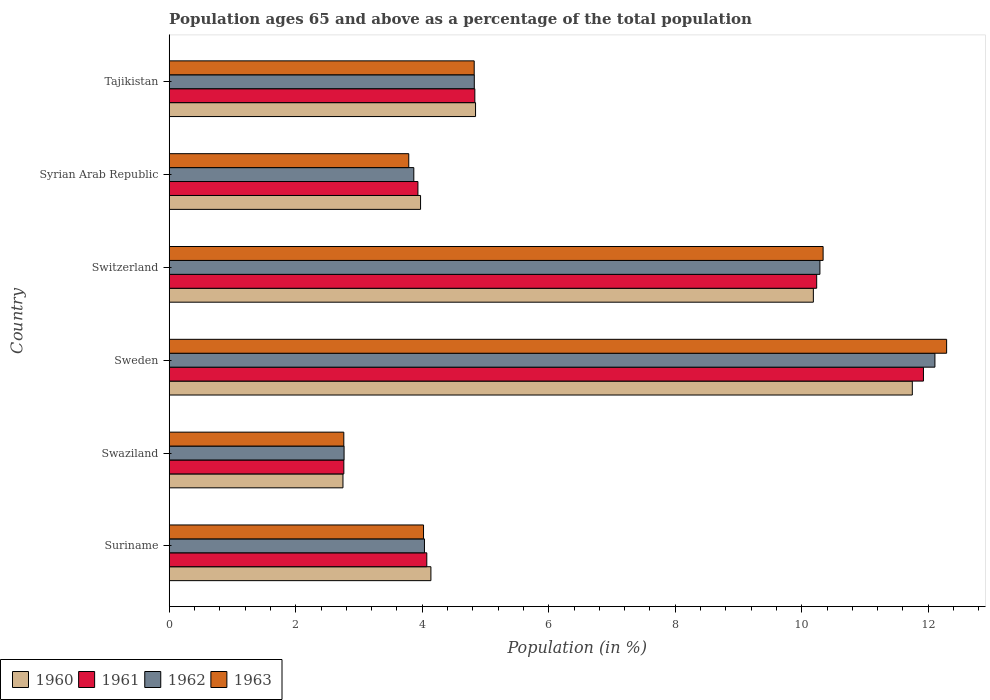How many different coloured bars are there?
Give a very brief answer. 4. Are the number of bars on each tick of the Y-axis equal?
Offer a terse response. Yes. What is the label of the 3rd group of bars from the top?
Provide a succinct answer. Switzerland. What is the percentage of the population ages 65 and above in 1963 in Sweden?
Give a very brief answer. 12.29. Across all countries, what is the maximum percentage of the population ages 65 and above in 1962?
Provide a short and direct response. 12.11. Across all countries, what is the minimum percentage of the population ages 65 and above in 1961?
Your answer should be very brief. 2.76. In which country was the percentage of the population ages 65 and above in 1963 maximum?
Your response must be concise. Sweden. In which country was the percentage of the population ages 65 and above in 1962 minimum?
Make the answer very short. Swaziland. What is the total percentage of the population ages 65 and above in 1960 in the graph?
Offer a very short reply. 37.63. What is the difference between the percentage of the population ages 65 and above in 1961 in Suriname and that in Syrian Arab Republic?
Your answer should be compact. 0.14. What is the difference between the percentage of the population ages 65 and above in 1960 in Switzerland and the percentage of the population ages 65 and above in 1962 in Sweden?
Your answer should be very brief. -1.92. What is the average percentage of the population ages 65 and above in 1961 per country?
Offer a very short reply. 6.29. What is the difference between the percentage of the population ages 65 and above in 1960 and percentage of the population ages 65 and above in 1963 in Swaziland?
Provide a short and direct response. -0.01. In how many countries, is the percentage of the population ages 65 and above in 1962 greater than 4 ?
Your answer should be compact. 4. What is the ratio of the percentage of the population ages 65 and above in 1961 in Swaziland to that in Switzerland?
Keep it short and to the point. 0.27. What is the difference between the highest and the second highest percentage of the population ages 65 and above in 1963?
Provide a succinct answer. 1.95. What is the difference between the highest and the lowest percentage of the population ages 65 and above in 1961?
Your answer should be very brief. 9.16. What does the 1st bar from the top in Sweden represents?
Your answer should be compact. 1963. Are all the bars in the graph horizontal?
Make the answer very short. Yes. Are the values on the major ticks of X-axis written in scientific E-notation?
Your response must be concise. No. Does the graph contain any zero values?
Make the answer very short. No. Where does the legend appear in the graph?
Offer a very short reply. Bottom left. How many legend labels are there?
Your answer should be compact. 4. How are the legend labels stacked?
Provide a succinct answer. Horizontal. What is the title of the graph?
Provide a short and direct response. Population ages 65 and above as a percentage of the total population. Does "2014" appear as one of the legend labels in the graph?
Offer a terse response. No. What is the label or title of the Y-axis?
Your answer should be compact. Country. What is the Population (in %) in 1960 in Suriname?
Provide a succinct answer. 4.14. What is the Population (in %) in 1961 in Suriname?
Make the answer very short. 4.07. What is the Population (in %) of 1962 in Suriname?
Ensure brevity in your answer.  4.04. What is the Population (in %) of 1963 in Suriname?
Your answer should be compact. 4.02. What is the Population (in %) of 1960 in Swaziland?
Provide a short and direct response. 2.75. What is the Population (in %) of 1961 in Swaziland?
Provide a succinct answer. 2.76. What is the Population (in %) in 1962 in Swaziland?
Provide a succinct answer. 2.76. What is the Population (in %) in 1963 in Swaziland?
Your response must be concise. 2.76. What is the Population (in %) in 1960 in Sweden?
Provide a succinct answer. 11.75. What is the Population (in %) in 1961 in Sweden?
Your response must be concise. 11.92. What is the Population (in %) of 1962 in Sweden?
Your response must be concise. 12.11. What is the Population (in %) in 1963 in Sweden?
Ensure brevity in your answer.  12.29. What is the Population (in %) in 1960 in Switzerland?
Ensure brevity in your answer.  10.18. What is the Population (in %) in 1961 in Switzerland?
Provide a short and direct response. 10.24. What is the Population (in %) in 1962 in Switzerland?
Give a very brief answer. 10.29. What is the Population (in %) in 1963 in Switzerland?
Your response must be concise. 10.34. What is the Population (in %) in 1960 in Syrian Arab Republic?
Make the answer very short. 3.97. What is the Population (in %) in 1961 in Syrian Arab Republic?
Make the answer very short. 3.93. What is the Population (in %) of 1962 in Syrian Arab Republic?
Offer a terse response. 3.87. What is the Population (in %) of 1963 in Syrian Arab Republic?
Make the answer very short. 3.79. What is the Population (in %) of 1960 in Tajikistan?
Offer a very short reply. 4.84. What is the Population (in %) of 1961 in Tajikistan?
Keep it short and to the point. 4.83. What is the Population (in %) of 1962 in Tajikistan?
Ensure brevity in your answer.  4.82. What is the Population (in %) in 1963 in Tajikistan?
Your answer should be compact. 4.82. Across all countries, what is the maximum Population (in %) in 1960?
Make the answer very short. 11.75. Across all countries, what is the maximum Population (in %) of 1961?
Provide a short and direct response. 11.92. Across all countries, what is the maximum Population (in %) of 1962?
Give a very brief answer. 12.11. Across all countries, what is the maximum Population (in %) in 1963?
Offer a terse response. 12.29. Across all countries, what is the minimum Population (in %) of 1960?
Your answer should be very brief. 2.75. Across all countries, what is the minimum Population (in %) in 1961?
Offer a terse response. 2.76. Across all countries, what is the minimum Population (in %) of 1962?
Provide a succinct answer. 2.76. Across all countries, what is the minimum Population (in %) of 1963?
Your response must be concise. 2.76. What is the total Population (in %) of 1960 in the graph?
Ensure brevity in your answer.  37.63. What is the total Population (in %) of 1961 in the graph?
Offer a very short reply. 37.76. What is the total Population (in %) in 1962 in the graph?
Your answer should be very brief. 37.88. What is the total Population (in %) of 1963 in the graph?
Provide a succinct answer. 38.02. What is the difference between the Population (in %) of 1960 in Suriname and that in Swaziland?
Give a very brief answer. 1.39. What is the difference between the Population (in %) in 1961 in Suriname and that in Swaziland?
Provide a short and direct response. 1.31. What is the difference between the Population (in %) in 1962 in Suriname and that in Swaziland?
Offer a very short reply. 1.27. What is the difference between the Population (in %) in 1963 in Suriname and that in Swaziland?
Ensure brevity in your answer.  1.26. What is the difference between the Population (in %) of 1960 in Suriname and that in Sweden?
Offer a terse response. -7.61. What is the difference between the Population (in %) in 1961 in Suriname and that in Sweden?
Provide a short and direct response. -7.85. What is the difference between the Population (in %) of 1962 in Suriname and that in Sweden?
Provide a succinct answer. -8.07. What is the difference between the Population (in %) in 1963 in Suriname and that in Sweden?
Keep it short and to the point. -8.27. What is the difference between the Population (in %) of 1960 in Suriname and that in Switzerland?
Provide a short and direct response. -6.05. What is the difference between the Population (in %) in 1961 in Suriname and that in Switzerland?
Your answer should be compact. -6.16. What is the difference between the Population (in %) of 1962 in Suriname and that in Switzerland?
Your answer should be compact. -6.25. What is the difference between the Population (in %) of 1963 in Suriname and that in Switzerland?
Provide a succinct answer. -6.32. What is the difference between the Population (in %) in 1960 in Suriname and that in Syrian Arab Republic?
Offer a very short reply. 0.16. What is the difference between the Population (in %) of 1961 in Suriname and that in Syrian Arab Republic?
Ensure brevity in your answer.  0.14. What is the difference between the Population (in %) of 1962 in Suriname and that in Syrian Arab Republic?
Your answer should be compact. 0.17. What is the difference between the Population (in %) in 1963 in Suriname and that in Syrian Arab Republic?
Your answer should be compact. 0.23. What is the difference between the Population (in %) of 1960 in Suriname and that in Tajikistan?
Offer a very short reply. -0.71. What is the difference between the Population (in %) of 1961 in Suriname and that in Tajikistan?
Provide a short and direct response. -0.76. What is the difference between the Population (in %) in 1962 in Suriname and that in Tajikistan?
Give a very brief answer. -0.79. What is the difference between the Population (in %) of 1963 in Suriname and that in Tajikistan?
Provide a short and direct response. -0.8. What is the difference between the Population (in %) of 1960 in Swaziland and that in Sweden?
Provide a short and direct response. -9. What is the difference between the Population (in %) of 1961 in Swaziland and that in Sweden?
Provide a short and direct response. -9.16. What is the difference between the Population (in %) of 1962 in Swaziland and that in Sweden?
Offer a very short reply. -9.34. What is the difference between the Population (in %) of 1963 in Swaziland and that in Sweden?
Provide a succinct answer. -9.53. What is the difference between the Population (in %) in 1960 in Swaziland and that in Switzerland?
Offer a terse response. -7.44. What is the difference between the Population (in %) in 1961 in Swaziland and that in Switzerland?
Your response must be concise. -7.48. What is the difference between the Population (in %) in 1962 in Swaziland and that in Switzerland?
Offer a very short reply. -7.52. What is the difference between the Population (in %) in 1963 in Swaziland and that in Switzerland?
Provide a short and direct response. -7.58. What is the difference between the Population (in %) in 1960 in Swaziland and that in Syrian Arab Republic?
Your answer should be very brief. -1.23. What is the difference between the Population (in %) in 1961 in Swaziland and that in Syrian Arab Republic?
Keep it short and to the point. -1.17. What is the difference between the Population (in %) in 1962 in Swaziland and that in Syrian Arab Republic?
Your response must be concise. -1.1. What is the difference between the Population (in %) of 1963 in Swaziland and that in Syrian Arab Republic?
Provide a short and direct response. -1.03. What is the difference between the Population (in %) in 1960 in Swaziland and that in Tajikistan?
Offer a terse response. -2.1. What is the difference between the Population (in %) of 1961 in Swaziland and that in Tajikistan?
Ensure brevity in your answer.  -2.07. What is the difference between the Population (in %) in 1962 in Swaziland and that in Tajikistan?
Offer a terse response. -2.06. What is the difference between the Population (in %) of 1963 in Swaziland and that in Tajikistan?
Ensure brevity in your answer.  -2.06. What is the difference between the Population (in %) of 1960 in Sweden and that in Switzerland?
Provide a succinct answer. 1.56. What is the difference between the Population (in %) in 1961 in Sweden and that in Switzerland?
Make the answer very short. 1.69. What is the difference between the Population (in %) in 1962 in Sweden and that in Switzerland?
Provide a succinct answer. 1.82. What is the difference between the Population (in %) of 1963 in Sweden and that in Switzerland?
Give a very brief answer. 1.95. What is the difference between the Population (in %) of 1960 in Sweden and that in Syrian Arab Republic?
Give a very brief answer. 7.77. What is the difference between the Population (in %) in 1961 in Sweden and that in Syrian Arab Republic?
Ensure brevity in your answer.  7.99. What is the difference between the Population (in %) of 1962 in Sweden and that in Syrian Arab Republic?
Make the answer very short. 8.24. What is the difference between the Population (in %) in 1963 in Sweden and that in Syrian Arab Republic?
Give a very brief answer. 8.5. What is the difference between the Population (in %) in 1960 in Sweden and that in Tajikistan?
Ensure brevity in your answer.  6.91. What is the difference between the Population (in %) in 1961 in Sweden and that in Tajikistan?
Ensure brevity in your answer.  7.09. What is the difference between the Population (in %) of 1962 in Sweden and that in Tajikistan?
Your answer should be compact. 7.28. What is the difference between the Population (in %) in 1963 in Sweden and that in Tajikistan?
Offer a terse response. 7.47. What is the difference between the Population (in %) of 1960 in Switzerland and that in Syrian Arab Republic?
Make the answer very short. 6.21. What is the difference between the Population (in %) of 1961 in Switzerland and that in Syrian Arab Republic?
Offer a terse response. 6.3. What is the difference between the Population (in %) in 1962 in Switzerland and that in Syrian Arab Republic?
Keep it short and to the point. 6.42. What is the difference between the Population (in %) in 1963 in Switzerland and that in Syrian Arab Republic?
Provide a succinct answer. 6.55. What is the difference between the Population (in %) of 1960 in Switzerland and that in Tajikistan?
Make the answer very short. 5.34. What is the difference between the Population (in %) in 1961 in Switzerland and that in Tajikistan?
Your response must be concise. 5.4. What is the difference between the Population (in %) in 1962 in Switzerland and that in Tajikistan?
Your response must be concise. 5.46. What is the difference between the Population (in %) of 1963 in Switzerland and that in Tajikistan?
Keep it short and to the point. 5.52. What is the difference between the Population (in %) in 1960 in Syrian Arab Republic and that in Tajikistan?
Keep it short and to the point. -0.87. What is the difference between the Population (in %) of 1961 in Syrian Arab Republic and that in Tajikistan?
Keep it short and to the point. -0.9. What is the difference between the Population (in %) of 1962 in Syrian Arab Republic and that in Tajikistan?
Your response must be concise. -0.96. What is the difference between the Population (in %) of 1963 in Syrian Arab Republic and that in Tajikistan?
Make the answer very short. -1.03. What is the difference between the Population (in %) in 1960 in Suriname and the Population (in %) in 1961 in Swaziland?
Offer a terse response. 1.38. What is the difference between the Population (in %) of 1960 in Suriname and the Population (in %) of 1962 in Swaziland?
Offer a terse response. 1.37. What is the difference between the Population (in %) of 1960 in Suriname and the Population (in %) of 1963 in Swaziland?
Offer a very short reply. 1.38. What is the difference between the Population (in %) of 1961 in Suriname and the Population (in %) of 1962 in Swaziland?
Offer a very short reply. 1.31. What is the difference between the Population (in %) in 1961 in Suriname and the Population (in %) in 1963 in Swaziland?
Offer a terse response. 1.31. What is the difference between the Population (in %) of 1962 in Suriname and the Population (in %) of 1963 in Swaziland?
Your response must be concise. 1.27. What is the difference between the Population (in %) in 1960 in Suriname and the Population (in %) in 1961 in Sweden?
Keep it short and to the point. -7.79. What is the difference between the Population (in %) of 1960 in Suriname and the Population (in %) of 1962 in Sweden?
Your answer should be very brief. -7.97. What is the difference between the Population (in %) in 1960 in Suriname and the Population (in %) in 1963 in Sweden?
Make the answer very short. -8.15. What is the difference between the Population (in %) of 1961 in Suriname and the Population (in %) of 1962 in Sweden?
Provide a short and direct response. -8.03. What is the difference between the Population (in %) in 1961 in Suriname and the Population (in %) in 1963 in Sweden?
Your answer should be very brief. -8.22. What is the difference between the Population (in %) of 1962 in Suriname and the Population (in %) of 1963 in Sweden?
Offer a very short reply. -8.26. What is the difference between the Population (in %) in 1960 in Suriname and the Population (in %) in 1961 in Switzerland?
Your answer should be compact. -6.1. What is the difference between the Population (in %) in 1960 in Suriname and the Population (in %) in 1962 in Switzerland?
Offer a very short reply. -6.15. What is the difference between the Population (in %) of 1960 in Suriname and the Population (in %) of 1963 in Switzerland?
Provide a short and direct response. -6.2. What is the difference between the Population (in %) of 1961 in Suriname and the Population (in %) of 1962 in Switzerland?
Keep it short and to the point. -6.22. What is the difference between the Population (in %) of 1961 in Suriname and the Population (in %) of 1963 in Switzerland?
Your response must be concise. -6.27. What is the difference between the Population (in %) in 1962 in Suriname and the Population (in %) in 1963 in Switzerland?
Keep it short and to the point. -6.3. What is the difference between the Population (in %) in 1960 in Suriname and the Population (in %) in 1961 in Syrian Arab Republic?
Provide a short and direct response. 0.21. What is the difference between the Population (in %) of 1960 in Suriname and the Population (in %) of 1962 in Syrian Arab Republic?
Your response must be concise. 0.27. What is the difference between the Population (in %) of 1960 in Suriname and the Population (in %) of 1963 in Syrian Arab Republic?
Provide a succinct answer. 0.35. What is the difference between the Population (in %) of 1961 in Suriname and the Population (in %) of 1962 in Syrian Arab Republic?
Your response must be concise. 0.21. What is the difference between the Population (in %) in 1961 in Suriname and the Population (in %) in 1963 in Syrian Arab Republic?
Provide a short and direct response. 0.29. What is the difference between the Population (in %) in 1962 in Suriname and the Population (in %) in 1963 in Syrian Arab Republic?
Your answer should be very brief. 0.25. What is the difference between the Population (in %) in 1960 in Suriname and the Population (in %) in 1961 in Tajikistan?
Make the answer very short. -0.69. What is the difference between the Population (in %) of 1960 in Suriname and the Population (in %) of 1962 in Tajikistan?
Your response must be concise. -0.69. What is the difference between the Population (in %) in 1960 in Suriname and the Population (in %) in 1963 in Tajikistan?
Provide a succinct answer. -0.68. What is the difference between the Population (in %) in 1961 in Suriname and the Population (in %) in 1962 in Tajikistan?
Offer a terse response. -0.75. What is the difference between the Population (in %) of 1961 in Suriname and the Population (in %) of 1963 in Tajikistan?
Offer a terse response. -0.75. What is the difference between the Population (in %) of 1962 in Suriname and the Population (in %) of 1963 in Tajikistan?
Your response must be concise. -0.79. What is the difference between the Population (in %) in 1960 in Swaziland and the Population (in %) in 1961 in Sweden?
Offer a very short reply. -9.18. What is the difference between the Population (in %) in 1960 in Swaziland and the Population (in %) in 1962 in Sweden?
Offer a terse response. -9.36. What is the difference between the Population (in %) in 1960 in Swaziland and the Population (in %) in 1963 in Sweden?
Make the answer very short. -9.54. What is the difference between the Population (in %) in 1961 in Swaziland and the Population (in %) in 1962 in Sweden?
Your answer should be very brief. -9.35. What is the difference between the Population (in %) of 1961 in Swaziland and the Population (in %) of 1963 in Sweden?
Give a very brief answer. -9.53. What is the difference between the Population (in %) of 1962 in Swaziland and the Population (in %) of 1963 in Sweden?
Make the answer very short. -9.53. What is the difference between the Population (in %) of 1960 in Swaziland and the Population (in %) of 1961 in Switzerland?
Make the answer very short. -7.49. What is the difference between the Population (in %) of 1960 in Swaziland and the Population (in %) of 1962 in Switzerland?
Provide a short and direct response. -7.54. What is the difference between the Population (in %) of 1960 in Swaziland and the Population (in %) of 1963 in Switzerland?
Ensure brevity in your answer.  -7.59. What is the difference between the Population (in %) in 1961 in Swaziland and the Population (in %) in 1962 in Switzerland?
Provide a succinct answer. -7.53. What is the difference between the Population (in %) in 1961 in Swaziland and the Population (in %) in 1963 in Switzerland?
Give a very brief answer. -7.58. What is the difference between the Population (in %) of 1962 in Swaziland and the Population (in %) of 1963 in Switzerland?
Make the answer very short. -7.57. What is the difference between the Population (in %) in 1960 in Swaziland and the Population (in %) in 1961 in Syrian Arab Republic?
Provide a succinct answer. -1.19. What is the difference between the Population (in %) in 1960 in Swaziland and the Population (in %) in 1962 in Syrian Arab Republic?
Provide a succinct answer. -1.12. What is the difference between the Population (in %) in 1960 in Swaziland and the Population (in %) in 1963 in Syrian Arab Republic?
Ensure brevity in your answer.  -1.04. What is the difference between the Population (in %) in 1961 in Swaziland and the Population (in %) in 1962 in Syrian Arab Republic?
Keep it short and to the point. -1.11. What is the difference between the Population (in %) of 1961 in Swaziland and the Population (in %) of 1963 in Syrian Arab Republic?
Provide a succinct answer. -1.03. What is the difference between the Population (in %) in 1962 in Swaziland and the Population (in %) in 1963 in Syrian Arab Republic?
Your response must be concise. -1.02. What is the difference between the Population (in %) in 1960 in Swaziland and the Population (in %) in 1961 in Tajikistan?
Ensure brevity in your answer.  -2.09. What is the difference between the Population (in %) of 1960 in Swaziland and the Population (in %) of 1962 in Tajikistan?
Your answer should be very brief. -2.08. What is the difference between the Population (in %) of 1960 in Swaziland and the Population (in %) of 1963 in Tajikistan?
Provide a short and direct response. -2.07. What is the difference between the Population (in %) in 1961 in Swaziland and the Population (in %) in 1962 in Tajikistan?
Give a very brief answer. -2.06. What is the difference between the Population (in %) of 1961 in Swaziland and the Population (in %) of 1963 in Tajikistan?
Provide a short and direct response. -2.06. What is the difference between the Population (in %) in 1962 in Swaziland and the Population (in %) in 1963 in Tajikistan?
Provide a succinct answer. -2.06. What is the difference between the Population (in %) of 1960 in Sweden and the Population (in %) of 1961 in Switzerland?
Your response must be concise. 1.51. What is the difference between the Population (in %) of 1960 in Sweden and the Population (in %) of 1962 in Switzerland?
Offer a terse response. 1.46. What is the difference between the Population (in %) of 1960 in Sweden and the Population (in %) of 1963 in Switzerland?
Give a very brief answer. 1.41. What is the difference between the Population (in %) of 1961 in Sweden and the Population (in %) of 1962 in Switzerland?
Offer a very short reply. 1.64. What is the difference between the Population (in %) in 1961 in Sweden and the Population (in %) in 1963 in Switzerland?
Make the answer very short. 1.59. What is the difference between the Population (in %) of 1962 in Sweden and the Population (in %) of 1963 in Switzerland?
Provide a succinct answer. 1.77. What is the difference between the Population (in %) in 1960 in Sweden and the Population (in %) in 1961 in Syrian Arab Republic?
Offer a very short reply. 7.82. What is the difference between the Population (in %) of 1960 in Sweden and the Population (in %) of 1962 in Syrian Arab Republic?
Your answer should be compact. 7.88. What is the difference between the Population (in %) in 1960 in Sweden and the Population (in %) in 1963 in Syrian Arab Republic?
Ensure brevity in your answer.  7.96. What is the difference between the Population (in %) in 1961 in Sweden and the Population (in %) in 1962 in Syrian Arab Republic?
Ensure brevity in your answer.  8.06. What is the difference between the Population (in %) of 1961 in Sweden and the Population (in %) of 1963 in Syrian Arab Republic?
Your answer should be very brief. 8.14. What is the difference between the Population (in %) of 1962 in Sweden and the Population (in %) of 1963 in Syrian Arab Republic?
Your answer should be very brief. 8.32. What is the difference between the Population (in %) of 1960 in Sweden and the Population (in %) of 1961 in Tajikistan?
Your response must be concise. 6.92. What is the difference between the Population (in %) of 1960 in Sweden and the Population (in %) of 1962 in Tajikistan?
Your answer should be compact. 6.93. What is the difference between the Population (in %) of 1960 in Sweden and the Population (in %) of 1963 in Tajikistan?
Make the answer very short. 6.93. What is the difference between the Population (in %) of 1961 in Sweden and the Population (in %) of 1962 in Tajikistan?
Keep it short and to the point. 7.1. What is the difference between the Population (in %) in 1961 in Sweden and the Population (in %) in 1963 in Tajikistan?
Provide a short and direct response. 7.1. What is the difference between the Population (in %) in 1962 in Sweden and the Population (in %) in 1963 in Tajikistan?
Give a very brief answer. 7.28. What is the difference between the Population (in %) of 1960 in Switzerland and the Population (in %) of 1961 in Syrian Arab Republic?
Make the answer very short. 6.25. What is the difference between the Population (in %) of 1960 in Switzerland and the Population (in %) of 1962 in Syrian Arab Republic?
Provide a succinct answer. 6.32. What is the difference between the Population (in %) in 1960 in Switzerland and the Population (in %) in 1963 in Syrian Arab Republic?
Ensure brevity in your answer.  6.4. What is the difference between the Population (in %) in 1961 in Switzerland and the Population (in %) in 1962 in Syrian Arab Republic?
Your response must be concise. 6.37. What is the difference between the Population (in %) of 1961 in Switzerland and the Population (in %) of 1963 in Syrian Arab Republic?
Provide a succinct answer. 6.45. What is the difference between the Population (in %) of 1962 in Switzerland and the Population (in %) of 1963 in Syrian Arab Republic?
Ensure brevity in your answer.  6.5. What is the difference between the Population (in %) of 1960 in Switzerland and the Population (in %) of 1961 in Tajikistan?
Offer a very short reply. 5.35. What is the difference between the Population (in %) of 1960 in Switzerland and the Population (in %) of 1962 in Tajikistan?
Keep it short and to the point. 5.36. What is the difference between the Population (in %) of 1960 in Switzerland and the Population (in %) of 1963 in Tajikistan?
Offer a terse response. 5.36. What is the difference between the Population (in %) in 1961 in Switzerland and the Population (in %) in 1962 in Tajikistan?
Offer a terse response. 5.41. What is the difference between the Population (in %) in 1961 in Switzerland and the Population (in %) in 1963 in Tajikistan?
Offer a terse response. 5.41. What is the difference between the Population (in %) in 1962 in Switzerland and the Population (in %) in 1963 in Tajikistan?
Ensure brevity in your answer.  5.47. What is the difference between the Population (in %) of 1960 in Syrian Arab Republic and the Population (in %) of 1961 in Tajikistan?
Offer a terse response. -0.86. What is the difference between the Population (in %) of 1960 in Syrian Arab Republic and the Population (in %) of 1962 in Tajikistan?
Your response must be concise. -0.85. What is the difference between the Population (in %) in 1960 in Syrian Arab Republic and the Population (in %) in 1963 in Tajikistan?
Provide a short and direct response. -0.85. What is the difference between the Population (in %) in 1961 in Syrian Arab Republic and the Population (in %) in 1962 in Tajikistan?
Your response must be concise. -0.89. What is the difference between the Population (in %) in 1961 in Syrian Arab Republic and the Population (in %) in 1963 in Tajikistan?
Keep it short and to the point. -0.89. What is the difference between the Population (in %) in 1962 in Syrian Arab Republic and the Population (in %) in 1963 in Tajikistan?
Make the answer very short. -0.95. What is the average Population (in %) of 1960 per country?
Provide a succinct answer. 6.27. What is the average Population (in %) of 1961 per country?
Provide a short and direct response. 6.29. What is the average Population (in %) of 1962 per country?
Ensure brevity in your answer.  6.31. What is the average Population (in %) of 1963 per country?
Your response must be concise. 6.34. What is the difference between the Population (in %) of 1960 and Population (in %) of 1961 in Suriname?
Keep it short and to the point. 0.07. What is the difference between the Population (in %) of 1960 and Population (in %) of 1962 in Suriname?
Your answer should be compact. 0.1. What is the difference between the Population (in %) in 1960 and Population (in %) in 1963 in Suriname?
Offer a terse response. 0.12. What is the difference between the Population (in %) of 1961 and Population (in %) of 1962 in Suriname?
Provide a short and direct response. 0.04. What is the difference between the Population (in %) in 1961 and Population (in %) in 1963 in Suriname?
Offer a terse response. 0.05. What is the difference between the Population (in %) of 1962 and Population (in %) of 1963 in Suriname?
Offer a terse response. 0.01. What is the difference between the Population (in %) in 1960 and Population (in %) in 1961 in Swaziland?
Provide a succinct answer. -0.01. What is the difference between the Population (in %) of 1960 and Population (in %) of 1962 in Swaziland?
Provide a short and direct response. -0.02. What is the difference between the Population (in %) in 1960 and Population (in %) in 1963 in Swaziland?
Offer a very short reply. -0.01. What is the difference between the Population (in %) of 1961 and Population (in %) of 1962 in Swaziland?
Keep it short and to the point. -0. What is the difference between the Population (in %) of 1961 and Population (in %) of 1963 in Swaziland?
Offer a very short reply. 0. What is the difference between the Population (in %) in 1962 and Population (in %) in 1963 in Swaziland?
Keep it short and to the point. 0. What is the difference between the Population (in %) in 1960 and Population (in %) in 1961 in Sweden?
Keep it short and to the point. -0.18. What is the difference between the Population (in %) in 1960 and Population (in %) in 1962 in Sweden?
Provide a succinct answer. -0.36. What is the difference between the Population (in %) of 1960 and Population (in %) of 1963 in Sweden?
Your answer should be very brief. -0.54. What is the difference between the Population (in %) in 1961 and Population (in %) in 1962 in Sweden?
Make the answer very short. -0.18. What is the difference between the Population (in %) in 1961 and Population (in %) in 1963 in Sweden?
Keep it short and to the point. -0.37. What is the difference between the Population (in %) of 1962 and Population (in %) of 1963 in Sweden?
Offer a terse response. -0.18. What is the difference between the Population (in %) of 1960 and Population (in %) of 1961 in Switzerland?
Provide a short and direct response. -0.05. What is the difference between the Population (in %) of 1960 and Population (in %) of 1962 in Switzerland?
Your response must be concise. -0.1. What is the difference between the Population (in %) in 1960 and Population (in %) in 1963 in Switzerland?
Provide a short and direct response. -0.15. What is the difference between the Population (in %) of 1961 and Population (in %) of 1962 in Switzerland?
Your answer should be compact. -0.05. What is the difference between the Population (in %) of 1961 and Population (in %) of 1963 in Switzerland?
Your answer should be very brief. -0.1. What is the difference between the Population (in %) in 1962 and Population (in %) in 1963 in Switzerland?
Ensure brevity in your answer.  -0.05. What is the difference between the Population (in %) of 1960 and Population (in %) of 1961 in Syrian Arab Republic?
Keep it short and to the point. 0.04. What is the difference between the Population (in %) in 1960 and Population (in %) in 1962 in Syrian Arab Republic?
Provide a succinct answer. 0.11. What is the difference between the Population (in %) of 1960 and Population (in %) of 1963 in Syrian Arab Republic?
Offer a very short reply. 0.19. What is the difference between the Population (in %) of 1961 and Population (in %) of 1962 in Syrian Arab Republic?
Provide a succinct answer. 0.07. What is the difference between the Population (in %) of 1961 and Population (in %) of 1963 in Syrian Arab Republic?
Your answer should be very brief. 0.14. What is the difference between the Population (in %) of 1962 and Population (in %) of 1963 in Syrian Arab Republic?
Your answer should be compact. 0.08. What is the difference between the Population (in %) of 1960 and Population (in %) of 1961 in Tajikistan?
Ensure brevity in your answer.  0.01. What is the difference between the Population (in %) in 1960 and Population (in %) in 1962 in Tajikistan?
Make the answer very short. 0.02. What is the difference between the Population (in %) of 1960 and Population (in %) of 1963 in Tajikistan?
Your answer should be compact. 0.02. What is the difference between the Population (in %) in 1961 and Population (in %) in 1962 in Tajikistan?
Offer a terse response. 0.01. What is the difference between the Population (in %) in 1961 and Population (in %) in 1963 in Tajikistan?
Ensure brevity in your answer.  0.01. What is the difference between the Population (in %) in 1962 and Population (in %) in 1963 in Tajikistan?
Give a very brief answer. 0. What is the ratio of the Population (in %) in 1960 in Suriname to that in Swaziland?
Offer a very short reply. 1.51. What is the ratio of the Population (in %) of 1961 in Suriname to that in Swaziland?
Your response must be concise. 1.48. What is the ratio of the Population (in %) of 1962 in Suriname to that in Swaziland?
Make the answer very short. 1.46. What is the ratio of the Population (in %) of 1963 in Suriname to that in Swaziland?
Ensure brevity in your answer.  1.46. What is the ratio of the Population (in %) of 1960 in Suriname to that in Sweden?
Your answer should be very brief. 0.35. What is the ratio of the Population (in %) of 1961 in Suriname to that in Sweden?
Give a very brief answer. 0.34. What is the ratio of the Population (in %) of 1963 in Suriname to that in Sweden?
Your answer should be compact. 0.33. What is the ratio of the Population (in %) in 1960 in Suriname to that in Switzerland?
Keep it short and to the point. 0.41. What is the ratio of the Population (in %) in 1961 in Suriname to that in Switzerland?
Ensure brevity in your answer.  0.4. What is the ratio of the Population (in %) in 1962 in Suriname to that in Switzerland?
Provide a succinct answer. 0.39. What is the ratio of the Population (in %) in 1963 in Suriname to that in Switzerland?
Provide a short and direct response. 0.39. What is the ratio of the Population (in %) of 1960 in Suriname to that in Syrian Arab Republic?
Give a very brief answer. 1.04. What is the ratio of the Population (in %) of 1961 in Suriname to that in Syrian Arab Republic?
Your answer should be very brief. 1.04. What is the ratio of the Population (in %) of 1962 in Suriname to that in Syrian Arab Republic?
Your answer should be very brief. 1.04. What is the ratio of the Population (in %) in 1963 in Suriname to that in Syrian Arab Republic?
Your response must be concise. 1.06. What is the ratio of the Population (in %) in 1960 in Suriname to that in Tajikistan?
Your answer should be very brief. 0.85. What is the ratio of the Population (in %) of 1961 in Suriname to that in Tajikistan?
Your answer should be compact. 0.84. What is the ratio of the Population (in %) in 1962 in Suriname to that in Tajikistan?
Your answer should be compact. 0.84. What is the ratio of the Population (in %) in 1963 in Suriname to that in Tajikistan?
Offer a very short reply. 0.83. What is the ratio of the Population (in %) in 1960 in Swaziland to that in Sweden?
Your answer should be very brief. 0.23. What is the ratio of the Population (in %) of 1961 in Swaziland to that in Sweden?
Offer a terse response. 0.23. What is the ratio of the Population (in %) of 1962 in Swaziland to that in Sweden?
Ensure brevity in your answer.  0.23. What is the ratio of the Population (in %) in 1963 in Swaziland to that in Sweden?
Give a very brief answer. 0.22. What is the ratio of the Population (in %) in 1960 in Swaziland to that in Switzerland?
Make the answer very short. 0.27. What is the ratio of the Population (in %) of 1961 in Swaziland to that in Switzerland?
Give a very brief answer. 0.27. What is the ratio of the Population (in %) in 1962 in Swaziland to that in Switzerland?
Your answer should be very brief. 0.27. What is the ratio of the Population (in %) in 1963 in Swaziland to that in Switzerland?
Keep it short and to the point. 0.27. What is the ratio of the Population (in %) in 1960 in Swaziland to that in Syrian Arab Republic?
Your response must be concise. 0.69. What is the ratio of the Population (in %) of 1961 in Swaziland to that in Syrian Arab Republic?
Offer a terse response. 0.7. What is the ratio of the Population (in %) in 1962 in Swaziland to that in Syrian Arab Republic?
Give a very brief answer. 0.71. What is the ratio of the Population (in %) in 1963 in Swaziland to that in Syrian Arab Republic?
Ensure brevity in your answer.  0.73. What is the ratio of the Population (in %) of 1960 in Swaziland to that in Tajikistan?
Make the answer very short. 0.57. What is the ratio of the Population (in %) in 1962 in Swaziland to that in Tajikistan?
Offer a terse response. 0.57. What is the ratio of the Population (in %) in 1963 in Swaziland to that in Tajikistan?
Make the answer very short. 0.57. What is the ratio of the Population (in %) in 1960 in Sweden to that in Switzerland?
Your answer should be compact. 1.15. What is the ratio of the Population (in %) of 1961 in Sweden to that in Switzerland?
Make the answer very short. 1.16. What is the ratio of the Population (in %) in 1962 in Sweden to that in Switzerland?
Your answer should be very brief. 1.18. What is the ratio of the Population (in %) of 1963 in Sweden to that in Switzerland?
Your response must be concise. 1.19. What is the ratio of the Population (in %) of 1960 in Sweden to that in Syrian Arab Republic?
Keep it short and to the point. 2.96. What is the ratio of the Population (in %) of 1961 in Sweden to that in Syrian Arab Republic?
Ensure brevity in your answer.  3.03. What is the ratio of the Population (in %) of 1962 in Sweden to that in Syrian Arab Republic?
Your answer should be very brief. 3.13. What is the ratio of the Population (in %) in 1963 in Sweden to that in Syrian Arab Republic?
Your response must be concise. 3.25. What is the ratio of the Population (in %) of 1960 in Sweden to that in Tajikistan?
Your response must be concise. 2.43. What is the ratio of the Population (in %) of 1961 in Sweden to that in Tajikistan?
Give a very brief answer. 2.47. What is the ratio of the Population (in %) in 1962 in Sweden to that in Tajikistan?
Give a very brief answer. 2.51. What is the ratio of the Population (in %) in 1963 in Sweden to that in Tajikistan?
Make the answer very short. 2.55. What is the ratio of the Population (in %) of 1960 in Switzerland to that in Syrian Arab Republic?
Your answer should be compact. 2.56. What is the ratio of the Population (in %) in 1961 in Switzerland to that in Syrian Arab Republic?
Offer a very short reply. 2.6. What is the ratio of the Population (in %) of 1962 in Switzerland to that in Syrian Arab Republic?
Your answer should be very brief. 2.66. What is the ratio of the Population (in %) of 1963 in Switzerland to that in Syrian Arab Republic?
Provide a succinct answer. 2.73. What is the ratio of the Population (in %) of 1960 in Switzerland to that in Tajikistan?
Keep it short and to the point. 2.1. What is the ratio of the Population (in %) of 1961 in Switzerland to that in Tajikistan?
Keep it short and to the point. 2.12. What is the ratio of the Population (in %) of 1962 in Switzerland to that in Tajikistan?
Your answer should be very brief. 2.13. What is the ratio of the Population (in %) in 1963 in Switzerland to that in Tajikistan?
Keep it short and to the point. 2.14. What is the ratio of the Population (in %) of 1960 in Syrian Arab Republic to that in Tajikistan?
Ensure brevity in your answer.  0.82. What is the ratio of the Population (in %) of 1961 in Syrian Arab Republic to that in Tajikistan?
Keep it short and to the point. 0.81. What is the ratio of the Population (in %) in 1962 in Syrian Arab Republic to that in Tajikistan?
Offer a terse response. 0.8. What is the ratio of the Population (in %) of 1963 in Syrian Arab Republic to that in Tajikistan?
Offer a terse response. 0.79. What is the difference between the highest and the second highest Population (in %) in 1960?
Ensure brevity in your answer.  1.56. What is the difference between the highest and the second highest Population (in %) of 1961?
Ensure brevity in your answer.  1.69. What is the difference between the highest and the second highest Population (in %) in 1962?
Your response must be concise. 1.82. What is the difference between the highest and the second highest Population (in %) in 1963?
Give a very brief answer. 1.95. What is the difference between the highest and the lowest Population (in %) of 1960?
Offer a very short reply. 9. What is the difference between the highest and the lowest Population (in %) in 1961?
Make the answer very short. 9.16. What is the difference between the highest and the lowest Population (in %) of 1962?
Your answer should be compact. 9.34. What is the difference between the highest and the lowest Population (in %) of 1963?
Offer a terse response. 9.53. 